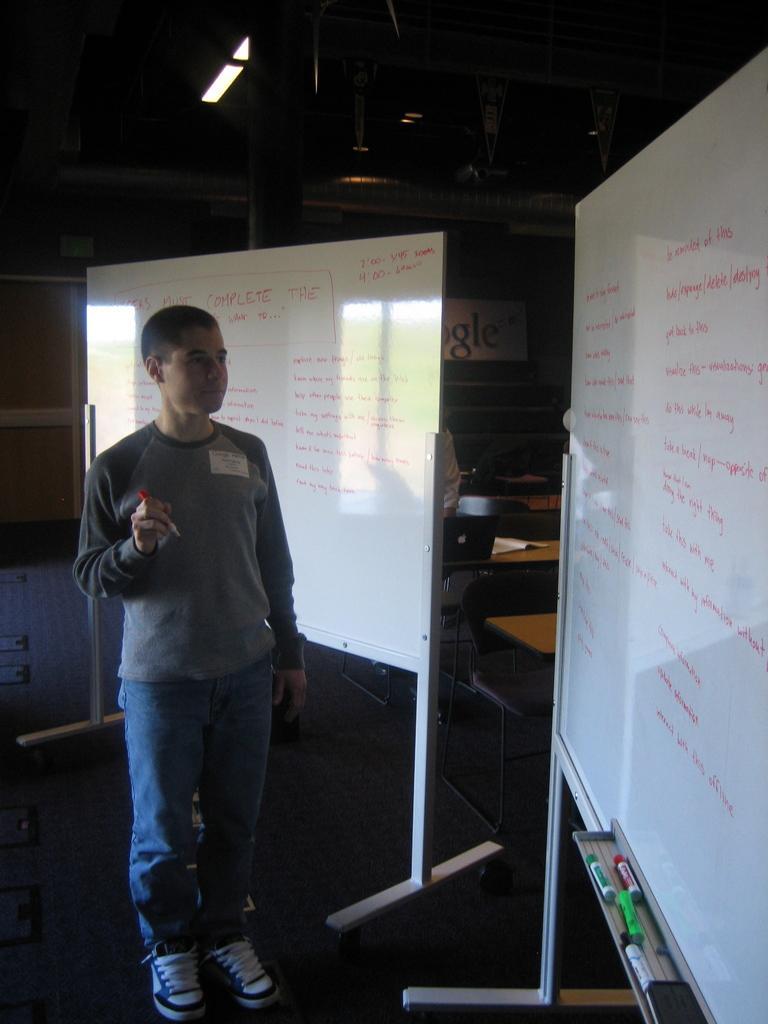Could you give a brief overview of what you see in this image? In this image, I can see a person standing. These are the two white boards with letters written on it. Behind the white boards, I can see tables, chairs and few other objects. At the top of the image, I can see the ceiling. 